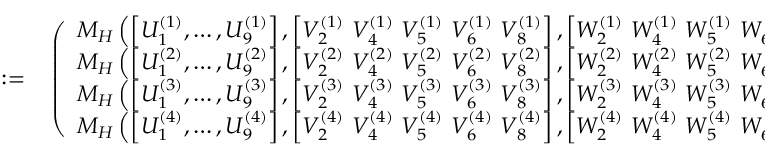Convert formula to latex. <formula><loc_0><loc_0><loc_500><loc_500>\begin{array} { r l } { \colon = } & \left ( \begin{array} { l } { M _ { H } \left ( \left [ { U } _ { 1 } ^ { ( 1 ) } , \dots , { U } _ { 9 } ^ { ( 1 ) } \right ] , \left [ { V } _ { 2 } ^ { ( 1 ) } { V } _ { 4 } ^ { ( 1 ) } { V } _ { 5 } ^ { ( 1 ) } { V } _ { 6 } ^ { ( 1 ) } { V } _ { 8 } ^ { ( 1 ) } \right ] , \left [ { W } _ { 2 } ^ { ( 1 ) } { W } _ { 4 } ^ { ( 1 ) } { W } _ { 5 } ^ { ( 1 ) } { W } _ { 6 } ^ { ( 1 ) } { W } _ { 8 } ^ { ( 1 ) } \right ] , \xi , \eta \right ) } \\ { M _ { H } \left ( \left [ { U } _ { 1 } ^ { ( 2 ) } , \dots , { U } _ { 9 } ^ { ( 2 ) } \right ] , \left [ { V } _ { 2 } ^ { ( 2 ) } { V } _ { 4 } ^ { ( 2 ) } { V } _ { 5 } ^ { ( 2 ) } { V } _ { 6 } ^ { ( 2 ) } { V } _ { 8 } ^ { ( 2 ) } \right ] , \left [ { W } _ { 2 } ^ { ( 2 ) } { W } _ { 4 } ^ { ( 2 ) } { W } _ { 5 } ^ { ( 2 ) } { W } _ { 6 } ^ { ( 2 ) } { W } _ { 8 } ^ { ( 2 ) } \right ] , \xi , \eta \right ) } \\ { M _ { H } \left ( \left [ { U } _ { 1 } ^ { ( 3 ) } , \dots , { U } _ { 9 } ^ { ( 3 ) } \right ] , \left [ { V } _ { 2 } ^ { ( 3 ) } { V } _ { 4 } ^ { ( 3 ) } { V } _ { 5 } ^ { ( 3 ) } { V } _ { 6 } ^ { ( 3 ) } { V } _ { 8 } ^ { ( 3 ) } \right ] , \left [ { W } _ { 2 } ^ { ( 3 ) } { W } _ { 4 } ^ { ( 3 ) } { W } _ { 5 } ^ { ( 3 ) } { W } _ { 6 } ^ { ( 3 ) } { W } _ { 8 } ^ { ( 3 ) } \right ] , \xi , \eta \right ) } \\ { M _ { H } \left ( \left [ { U } _ { 1 } ^ { ( 4 ) } , \dots , { U } _ { 9 } ^ { ( 4 ) } \right ] , \left [ { V } _ { 2 } ^ { ( 4 ) } { V } _ { 4 } ^ { ( 4 ) } { V } _ { 5 } ^ { ( 4 ) } { V } _ { 6 } ^ { ( 4 ) } { V } _ { 8 } ^ { ( 4 ) } \right ] , \left [ { W } _ { 2 } ^ { ( 4 ) } { W } _ { 4 } ^ { ( 4 ) } { W } _ { 5 } ^ { ( 4 ) } { W } _ { 6 } ^ { ( 4 ) } { W } _ { 8 } ^ { ( 4 ) } \right ] , \xi , \eta \right ) } \end{array} \right ) , } \end{array}</formula> 